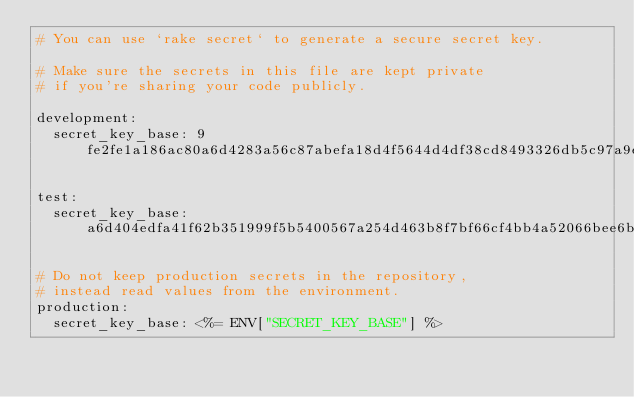<code> <loc_0><loc_0><loc_500><loc_500><_YAML_># You can use `rake secret` to generate a secure secret key.

# Make sure the secrets in this file are kept private
# if you're sharing your code publicly.

development:
  secret_key_base: 9fe2fe1a186ac80a6d4283a56c87abefa18d4f5644d4df38cd8493326db5c97a9eba42f2e2fef05b555d2c4ecf5458085e607ea1aa7f12e2d3c933b67e29ea52

test:
  secret_key_base: a6d404edfa41f62b351999f5b5400567a254d463b8f7bf66cf4bb4a52066bee6bf05a246acd3b3c0665d9d4c55f57a5599baa643026a7a320338e559fcd22630

# Do not keep production secrets in the repository,
# instead read values from the environment.
production:
  secret_key_base: <%= ENV["SECRET_KEY_BASE"] %>
</code> 